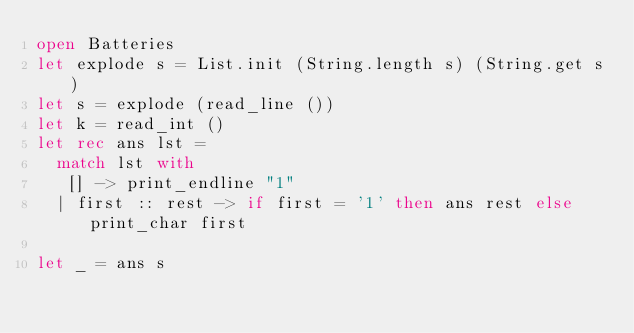Convert code to text. <code><loc_0><loc_0><loc_500><loc_500><_OCaml_>open Batteries
let explode s = List.init (String.length s) (String.get s)
let s = explode (read_line ())
let k = read_int ()
let rec ans lst = 
  match lst with
   [] -> print_endline "1"
  | first :: rest -> if first = '1' then ans rest else print_char first

let _ = ans s</code> 